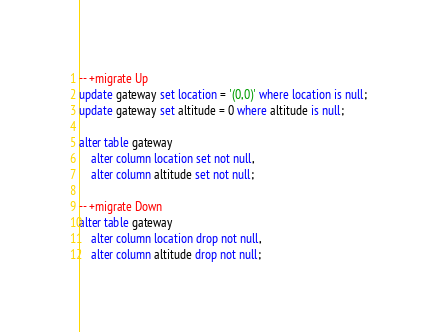Convert code to text. <code><loc_0><loc_0><loc_500><loc_500><_SQL_>-- +migrate Up
update gateway set location = '(0,0)' where location is null;
update gateway set altitude = 0 where altitude is null;

alter table gateway
	alter column location set not null,
	alter column altitude set not null;

-- +migrate Down
alter table gateway
	alter column location drop not null,
	alter column altitude drop not null;
</code> 